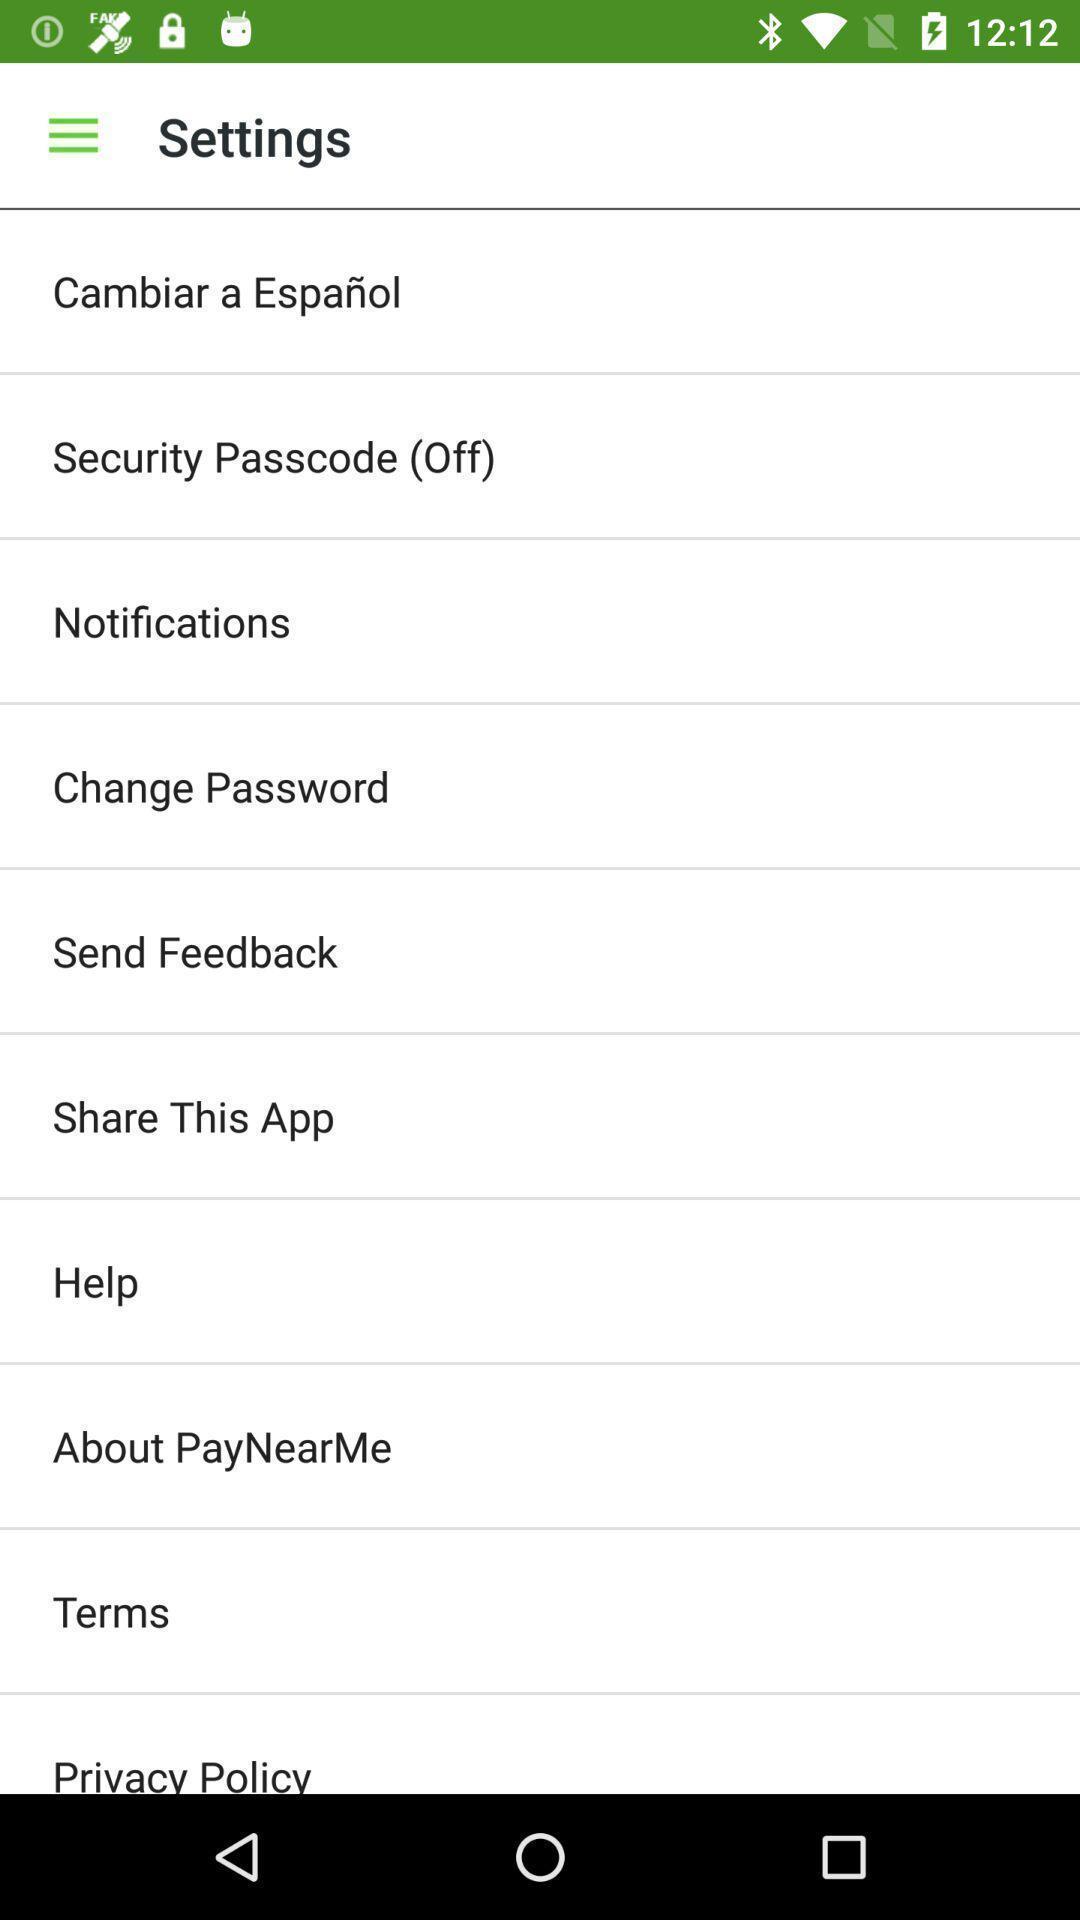Provide a detailed account of this screenshot. Settings page. 